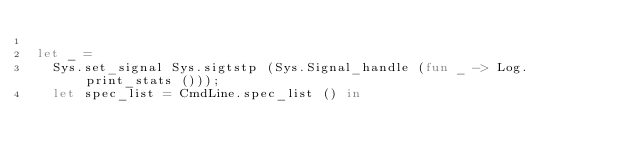<code> <loc_0><loc_0><loc_500><loc_500><_OCaml_>
let _ =
  Sys.set_signal Sys.sigtstp (Sys.Signal_handle (fun _ -> Log.print_stats ()));
  let spec_list = CmdLine.spec_list () in</code> 